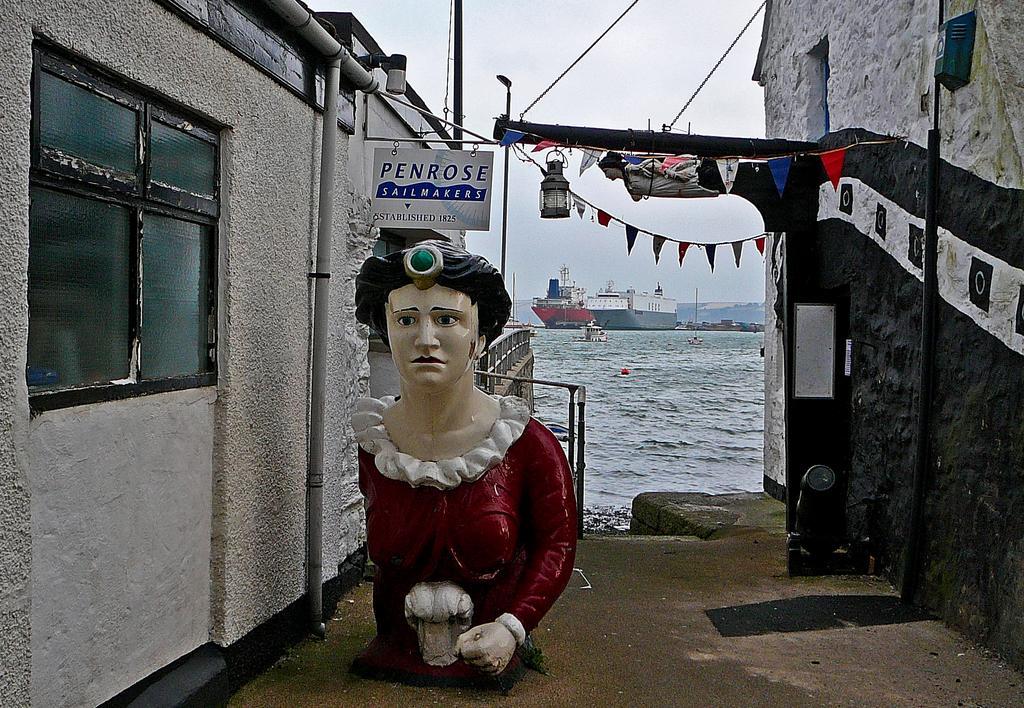Can you describe this image briefly? In this image, at the middle there is a red color statue, at the left side there is a wall and there is a glass window, at the right side there is a black color wall, at the background there is a sea and there is water, at the top there is a sky. 